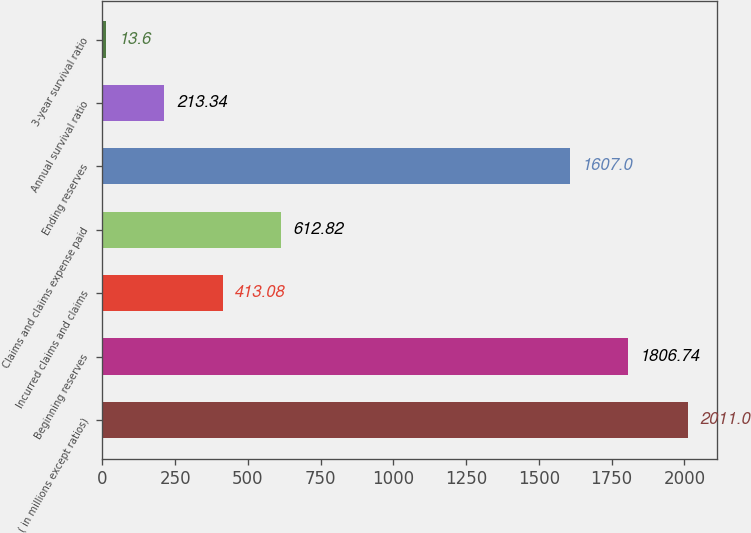Convert chart. <chart><loc_0><loc_0><loc_500><loc_500><bar_chart><fcel>( in millions except ratios)<fcel>Beginning reserves<fcel>Incurred claims and claims<fcel>Claims and claims expense paid<fcel>Ending reserves<fcel>Annual survival ratio<fcel>3-year survival ratio<nl><fcel>2011<fcel>1806.74<fcel>413.08<fcel>612.82<fcel>1607<fcel>213.34<fcel>13.6<nl></chart> 